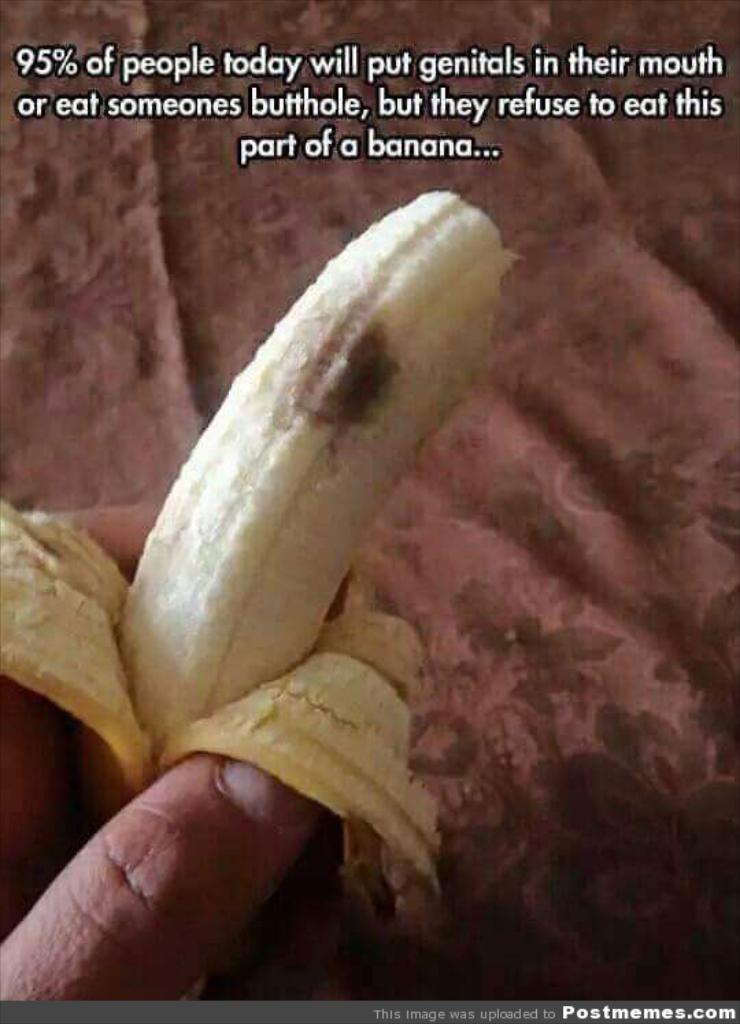What is the main subject of the image? There is a person in the image. What is the person holding in the image? The person is holding a banana. What can be seen in the background of the image? There is a bed sheet in the background of the image. What is written or visible at the top of the image? There is text visible at the top of the image. Can you explain the snail's theory about the spot on the bed sheet in the image? There is no snail or spot on the bed sheet present in the image, so it is not possible to discuss a snail's theory about the spot. 